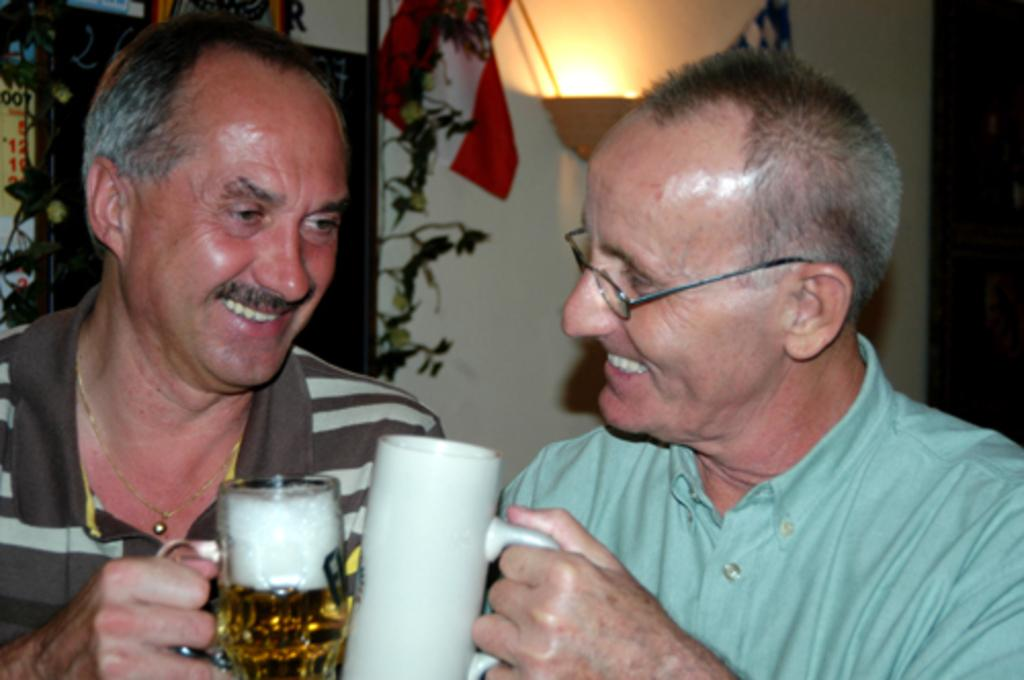How many people are in the image? There are two men in the image. What are the men holding in the image? The men are holding cups. What is the facial expression of the men in the image? The men are smiling. What can be seen in the background of the image? There is light visible in the background of the image. What type of pet is sitting on the desk in the image? There is no pet visible in the image; it only features two men holding cups and smiling. 